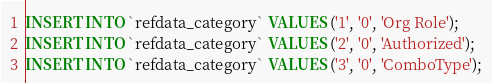<code> <loc_0><loc_0><loc_500><loc_500><_SQL_>INSERT INTO `refdata_category` VALUES ('1', '0', 'Org Role');
INSERT INTO `refdata_category` VALUES ('2', '0', 'Authorized');
INSERT INTO `refdata_category` VALUES ('3', '0', 'ComboType');
</code> 